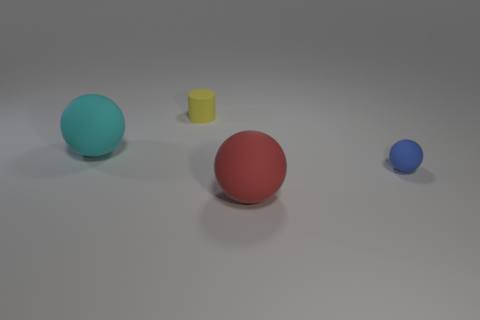Subtract 1 balls. How many balls are left? 2 Add 4 tiny purple things. How many objects exist? 8 Subtract all balls. How many objects are left? 1 Subtract all tiny blocks. Subtract all small matte objects. How many objects are left? 2 Add 4 spheres. How many spheres are left? 7 Add 3 small brown matte blocks. How many small brown matte blocks exist? 3 Subtract 0 brown spheres. How many objects are left? 4 